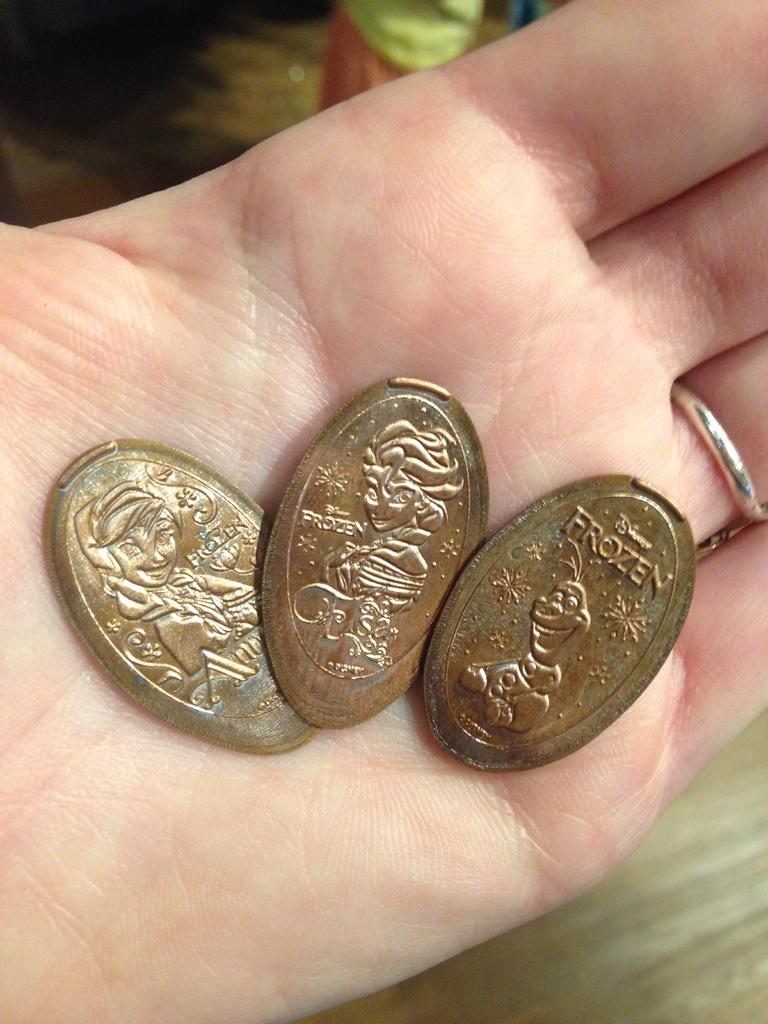What movie are these representing?
Keep it short and to the point. Frozen. 